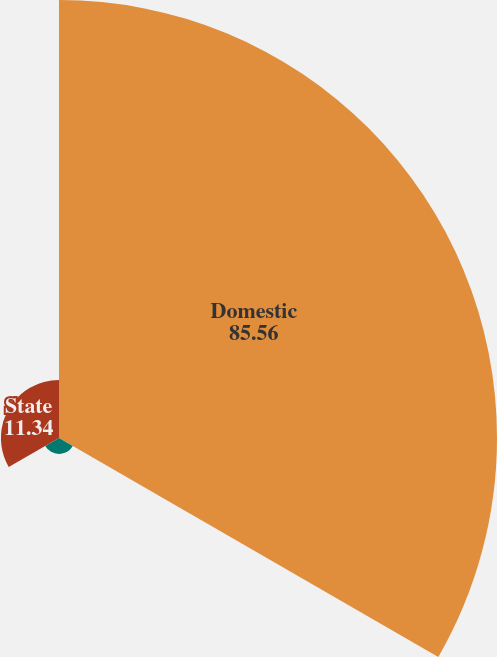<chart> <loc_0><loc_0><loc_500><loc_500><pie_chart><fcel>Domestic<fcel>Foreign<fcel>State<nl><fcel>85.56%<fcel>3.1%<fcel>11.34%<nl></chart> 